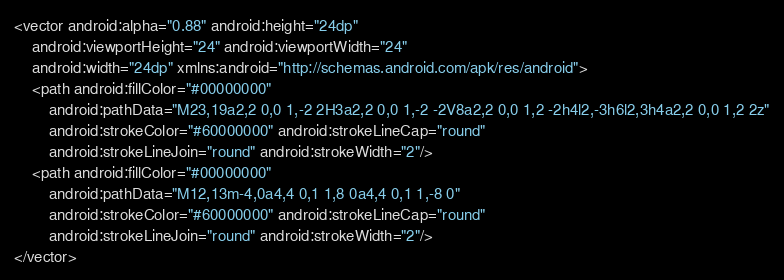<code> <loc_0><loc_0><loc_500><loc_500><_XML_><vector android:alpha="0.88" android:height="24dp"
    android:viewportHeight="24" android:viewportWidth="24"
    android:width="24dp" xmlns:android="http://schemas.android.com/apk/res/android">
    <path android:fillColor="#00000000"
        android:pathData="M23,19a2,2 0,0 1,-2 2H3a2,2 0,0 1,-2 -2V8a2,2 0,0 1,2 -2h4l2,-3h6l2,3h4a2,2 0,0 1,2 2z"
        android:strokeColor="#60000000" android:strokeLineCap="round"
        android:strokeLineJoin="round" android:strokeWidth="2"/>
    <path android:fillColor="#00000000"
        android:pathData="M12,13m-4,0a4,4 0,1 1,8 0a4,4 0,1 1,-8 0"
        android:strokeColor="#60000000" android:strokeLineCap="round"
        android:strokeLineJoin="round" android:strokeWidth="2"/>
</vector>
</code> 